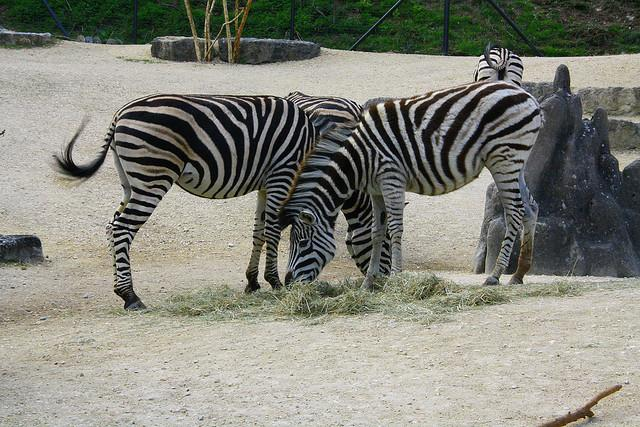What is fully visible on the animal on the left?

Choices:
A) horn
B) wing
C) tusk
D) tail tail 